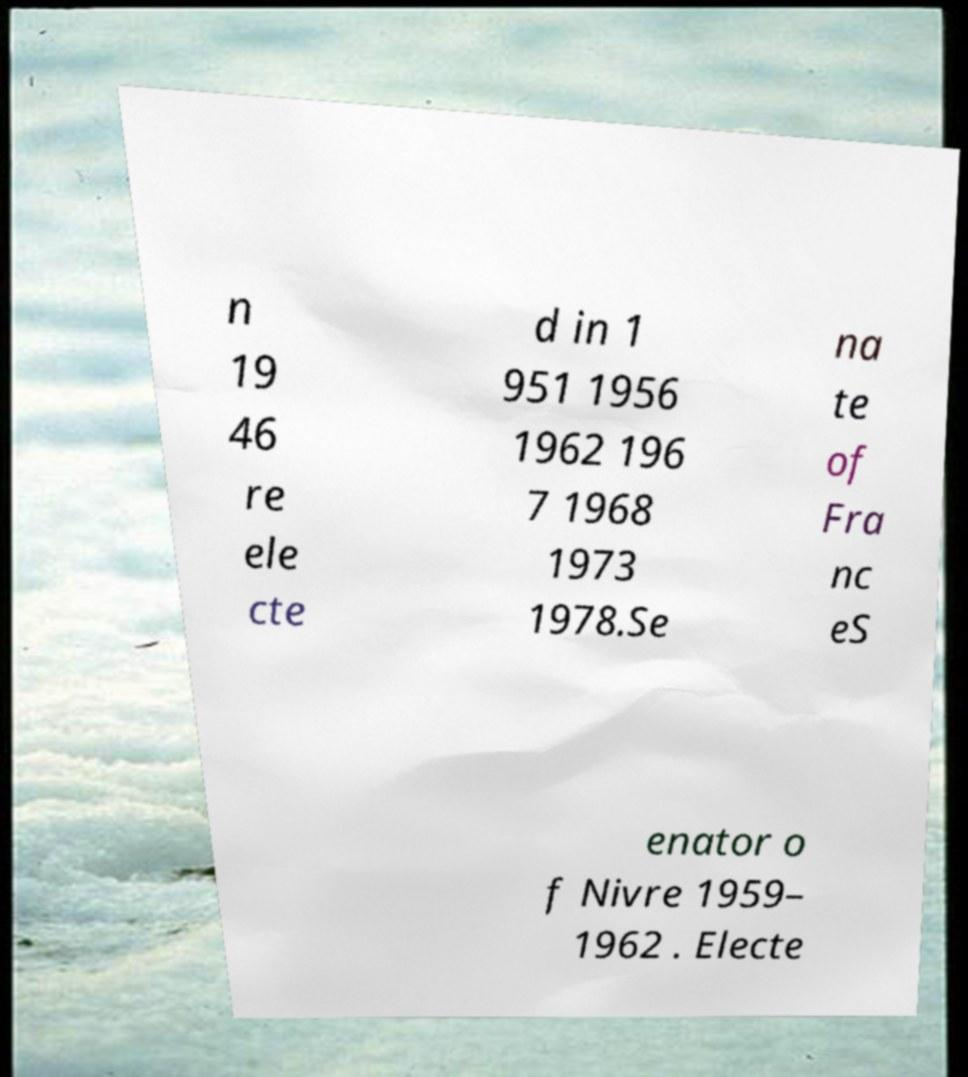Please read and relay the text visible in this image. What does it say? n 19 46 re ele cte d in 1 951 1956 1962 196 7 1968 1973 1978.Se na te of Fra nc eS enator o f Nivre 1959– 1962 . Electe 